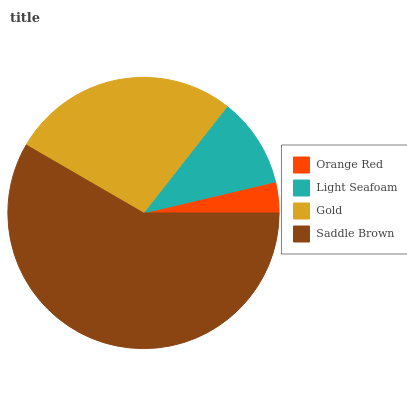Is Orange Red the minimum?
Answer yes or no. Yes. Is Saddle Brown the maximum?
Answer yes or no. Yes. Is Light Seafoam the minimum?
Answer yes or no. No. Is Light Seafoam the maximum?
Answer yes or no. No. Is Light Seafoam greater than Orange Red?
Answer yes or no. Yes. Is Orange Red less than Light Seafoam?
Answer yes or no. Yes. Is Orange Red greater than Light Seafoam?
Answer yes or no. No. Is Light Seafoam less than Orange Red?
Answer yes or no. No. Is Gold the high median?
Answer yes or no. Yes. Is Light Seafoam the low median?
Answer yes or no. Yes. Is Orange Red the high median?
Answer yes or no. No. Is Orange Red the low median?
Answer yes or no. No. 